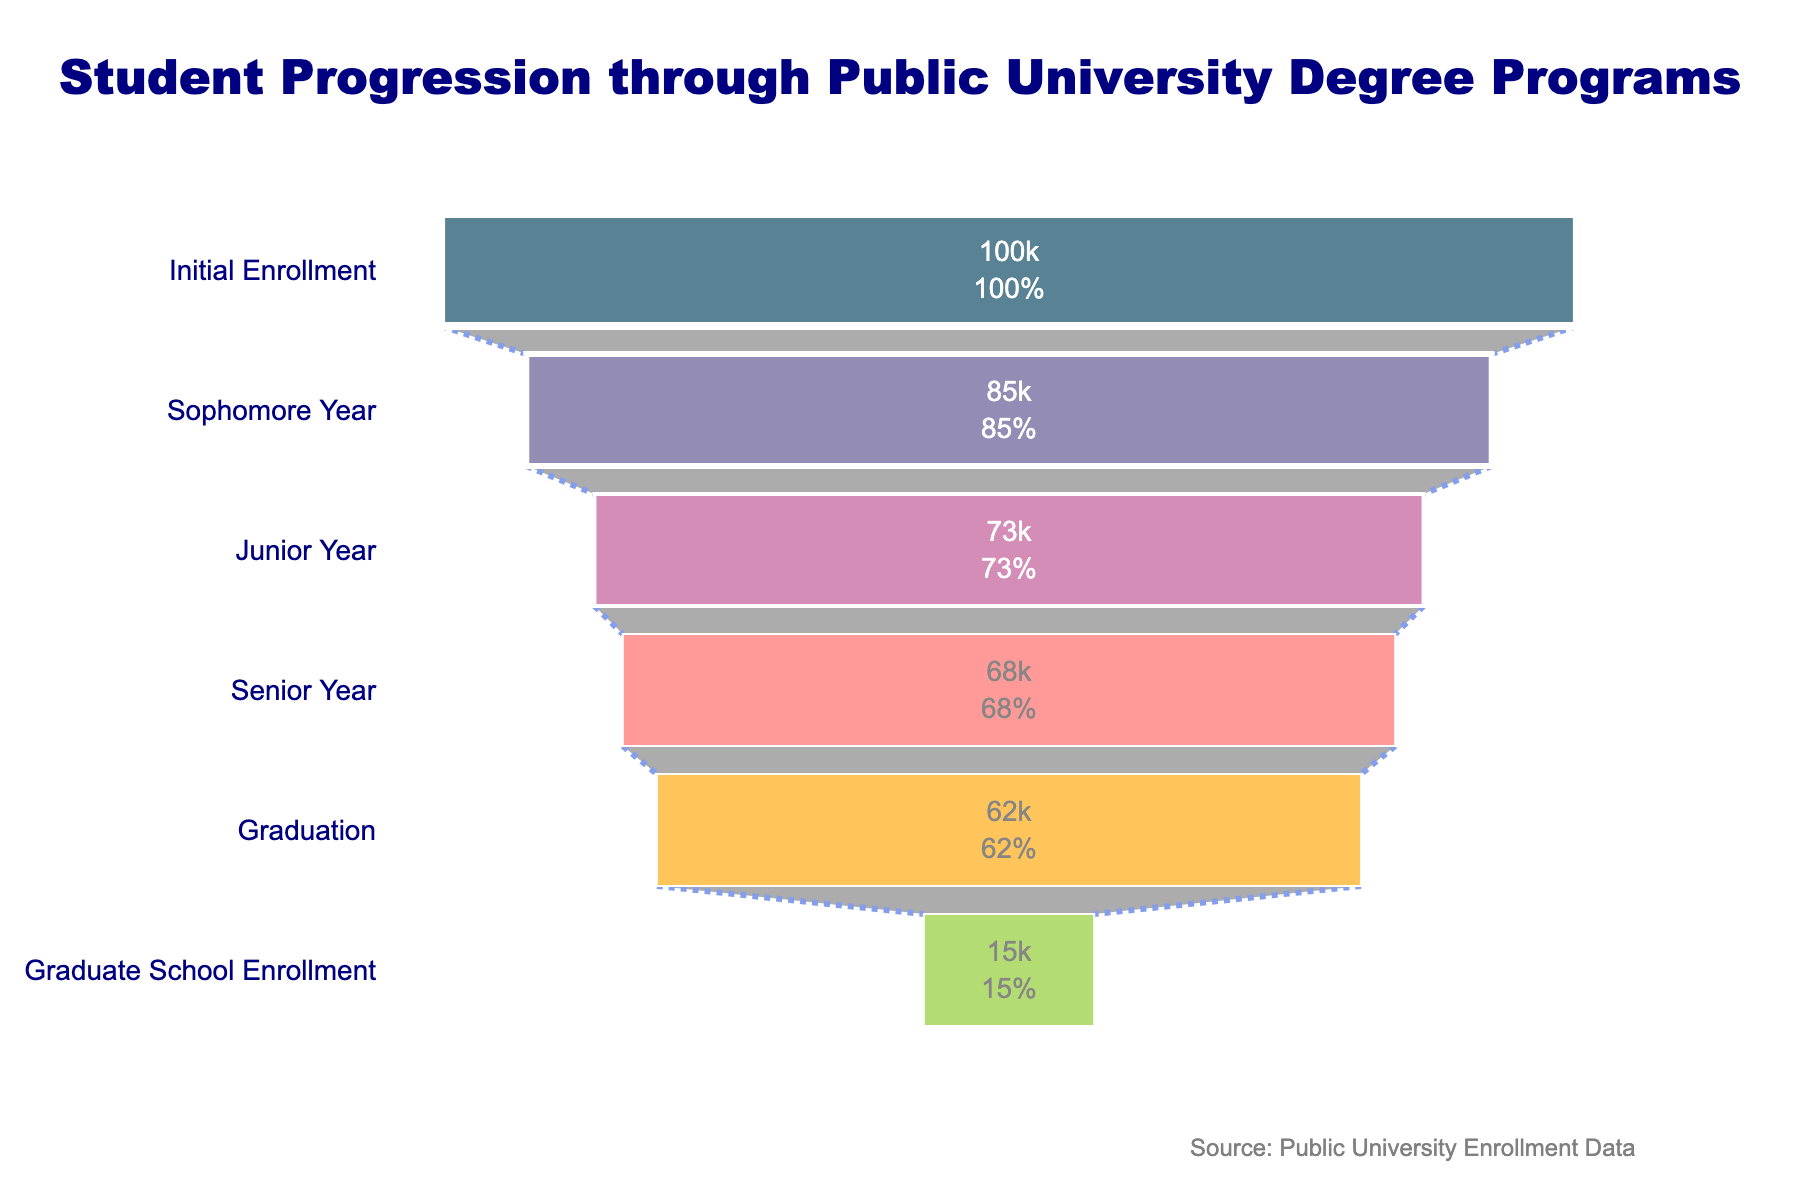What's the title of the figure? The title is usually prominently displayed at the top of the figure. Here, it reads "Student Progression through Public University Degree Programs".
Answer: Student Progression through Public University Degree Programs How many students initially enrolled in the program? The first stage of the funnel chart is labeled "Initial Enrollment" with the corresponding number of students listed inside the bar. The number is 100,000.
Answer: 100,000 What percentage of the initial enrollment reaches graduation? To determine the percentage, divide the number of students at the Graduation stage by the number of students at Initial Enrollment and multiply by 100: (62,000 / 100,000) * 100.
Answer: 62% What is the difference in the number of students between the Sophomore Year and Junior Year stages? Subtract the number of students in the Junior Year from the number of students in the Sophomore Year: 85,000 - 73,000.
Answer: 12,000 Which stage has the largest drop in student numbers? Compare the differences between consecutive stages: 
Initial Enrollment to Sophomore Year: 100,000 - 85,000 = 15,000 
Sophomore Year to Junior Year: 85,000 - 73,000 = 12,000 
Junior Year to Senior Year: 73,000 - 68,000 = 5,000 
Senior Year to Graduation: 68,000 - 62,000 = 6,000 
Graduation to Graduate School Enrollment: 62,000 - 15,000 = 47,000 
The largest drop is from Graduation to Graduate School Enrollment.
Answer: Graduation to Graduate School Enrollment How many students enroll in Graduate School after graduation? The stage labeled "Graduate School Enrollment" shows the number of students continuing their education after graduation. This number is 15,000.
Answer: 15,000 What is the total number of students lost from Initial Enrollment to Graduate School Enrollment? Subtract the number of students at Graduate School Enrollment from Initial Enrollment: 100,000 - 15,000.
Answer: 85,000 What percentage of students remain after each year? For each stage, divide the number of students by the Initial Enrollment and multiply by 100:
Sophomore Year: (85,000 / 100,000) * 100 = 85%
Junior Year: (73,000 / 100,000) * 100 = 73%
Senior Year: (68,000 / 100,000) * 100 = 68% 
Graduation: (62,000 / 100,000) * 100 = 62%
Graduate School Enrollment: (15,000 / 100,000) * 100 = 15%
Answer: Sophomore: 85%, Junior: 73%, Senior: 68%, Graduation: 62%, Graduate: 15% What is the average annual dropout rate from Initial Enrollment to Graduation? The dropout rate for each interval is calculated by the difference divided by the number of years. Here, the dropout rates are:
First year: (100,000 - 85,000) / 1 = 15,000
Second year: (85,000 - 73,000) / 1 = 12,000
Third year: (73,000 - 68,000) / 1 = 5,000
Fourth year: (68,000 - 62,000) / 1 = 6,000
Average annual dropout rate: (15,000 + 12,000 + 5,000 + 6,000) / 4.
Answer: 9,500 